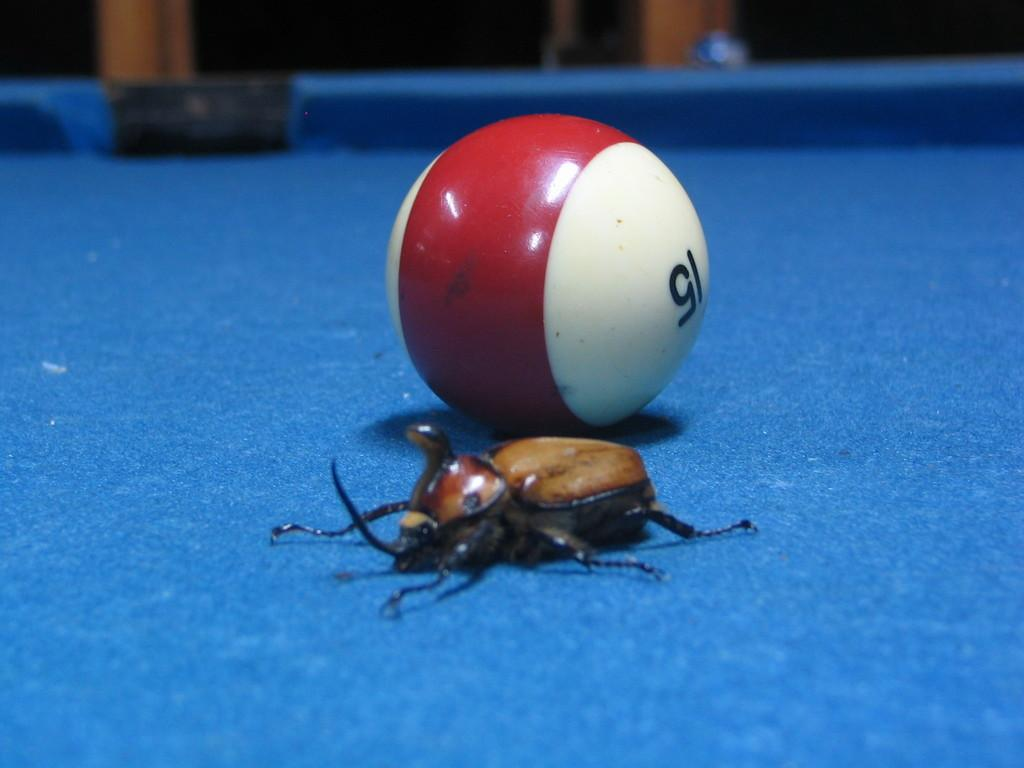What color is the surface that the ball is on in the image? The surface is blue. What object is on the blue surface in the image? There is a ball on the blue surface. Are there any living creatures visible in the image? Yes, there is a bug in the image. How does the bug pull the ball on the blue surface in the image? The bug does not pull the ball in the image; it is not interacting with the ball. 